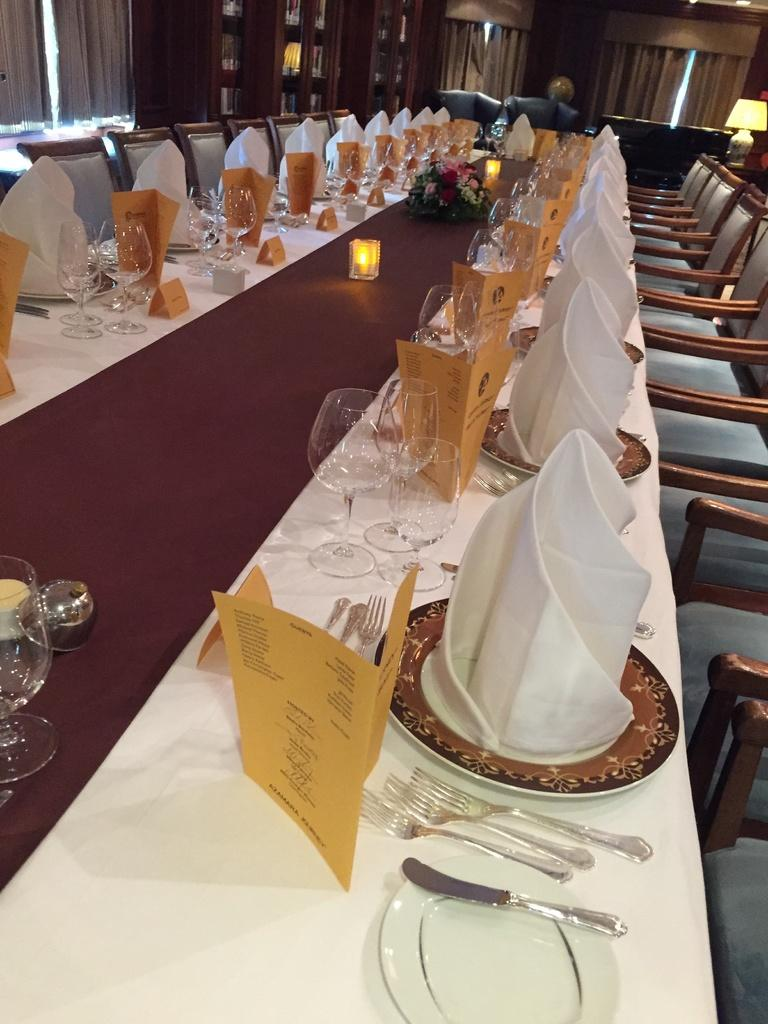What type of furniture is visible in the image? There are chairs and a table in the image. What items are placed on the table? Menu cards, spoons, glasses, plates, and towels are visible on the table. How many boys are sitting on the sofa in the image? There is no sofa or boys present in the image. What type of property is being sold in the image? There is no property being sold in the image; it features chairs, a table, and items on the table. 